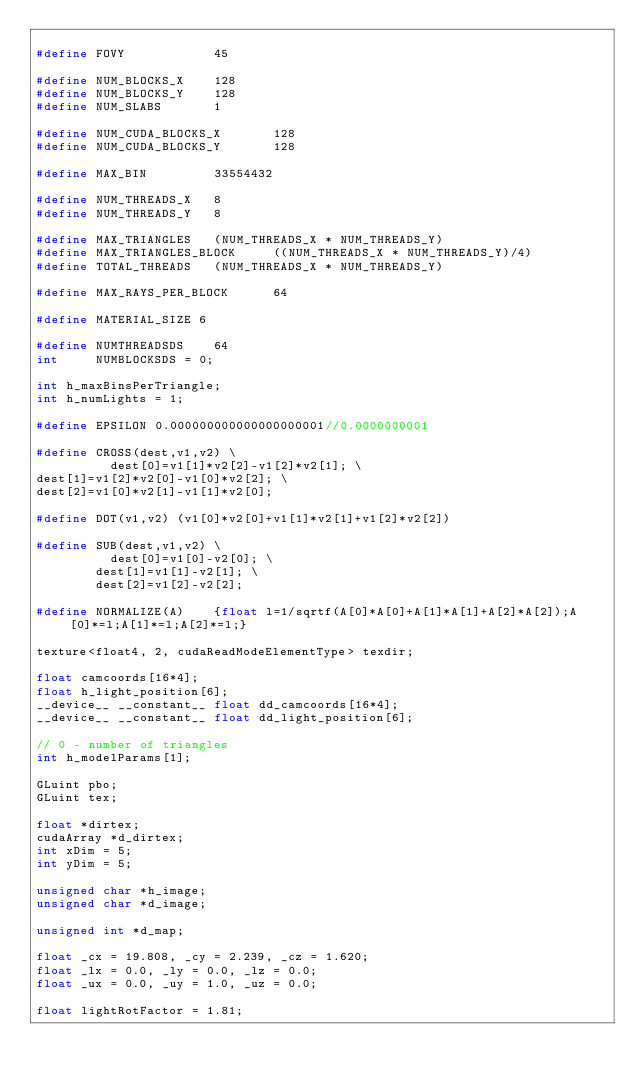Convert code to text. <code><loc_0><loc_0><loc_500><loc_500><_C_>
#define FOVY            45

#define NUM_BLOCKS_X    128
#define NUM_BLOCKS_Y    128
#define NUM_SLABS       1

#define NUM_CUDA_BLOCKS_X       128
#define NUM_CUDA_BLOCKS_Y       128

#define MAX_BIN         33554432

#define NUM_THREADS_X   8
#define NUM_THREADS_Y   8

#define MAX_TRIANGLES   (NUM_THREADS_X * NUM_THREADS_Y)
#define MAX_TRIANGLES_BLOCK     ((NUM_THREADS_X * NUM_THREADS_Y)/4)
#define TOTAL_THREADS   (NUM_THREADS_X * NUM_THREADS_Y)

#define MAX_RAYS_PER_BLOCK      64

#define MATERIAL_SIZE	6

#define NUMTHREADSDS    64
int     NUMBLOCKSDS = 0;

int h_maxBinsPerTriangle;
int h_numLights = 1;

#define EPSILON	0.000000000000000000001//0.0000000001

#define CROSS(dest,v1,v2) \
	        dest[0]=v1[1]*v2[2]-v1[2]*v2[1]; \
dest[1]=v1[2]*v2[0]-v1[0]*v2[2]; \
dest[2]=v1[0]*v2[1]-v1[1]*v2[0];

#define DOT(v1,v2) (v1[0]*v2[0]+v1[1]*v2[1]+v1[2]*v2[2])

#define SUB(dest,v1,v2) \
	        dest[0]=v1[0]-v2[0]; \
        dest[1]=v1[1]-v2[1]; \
        dest[2]=v1[2]-v2[2];

#define NORMALIZE(A)    {float l=1/sqrtf(A[0]*A[0]+A[1]*A[1]+A[2]*A[2]);A[0]*=l;A[1]*=l;A[2]*=l;}

texture<float4, 2, cudaReadModeElementType> texdir;

float camcoords[16*4];
float h_light_position[6];
__device__ __constant__ float dd_camcoords[16*4];
__device__ __constant__ float dd_light_position[6];

// 0 - number of triangles
int h_modelParams[1];

GLuint pbo;
GLuint tex;

float *dirtex;
cudaArray *d_dirtex;
int xDim = 5;
int yDim = 5;

unsigned char *h_image;
unsigned char *d_image;

unsigned int *d_map;

float _cx = 19.808, _cy = 2.239, _cz = 1.620;
float _lx = 0.0, _ly = 0.0, _lz = 0.0;
float _ux = 0.0, _uy = 1.0, _uz = 0.0;

float lightRotFactor = 1.81;
</code> 